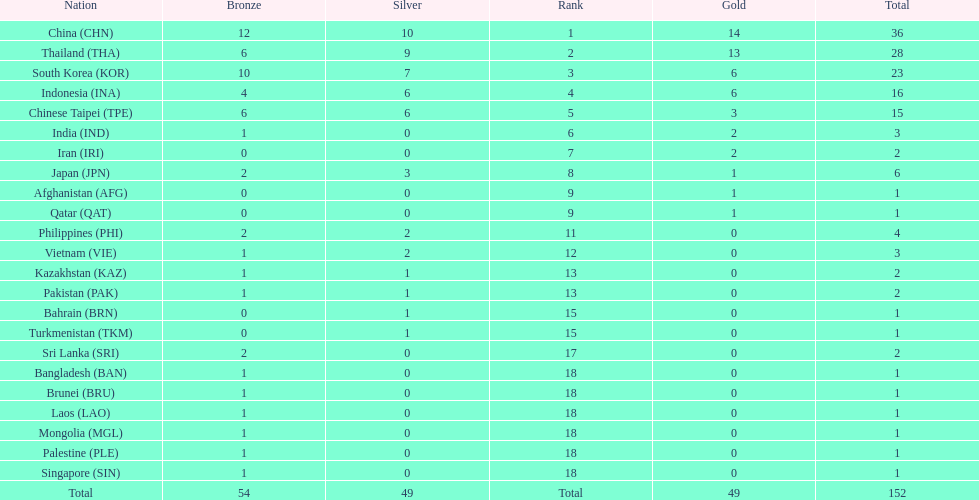How many more medals did india earn compared to pakistan? 1. 